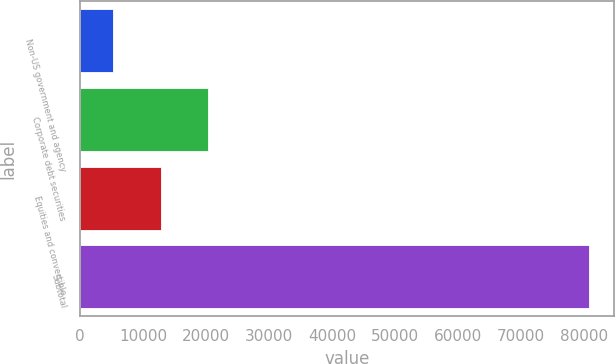Convert chart to OTSL. <chart><loc_0><loc_0><loc_500><loc_500><bar_chart><fcel>Non-US government and agency<fcel>Corporate debt securities<fcel>Equities and convertible<fcel>Subtotal<nl><fcel>5260<fcel>20352.6<fcel>12806.3<fcel>80723<nl></chart> 